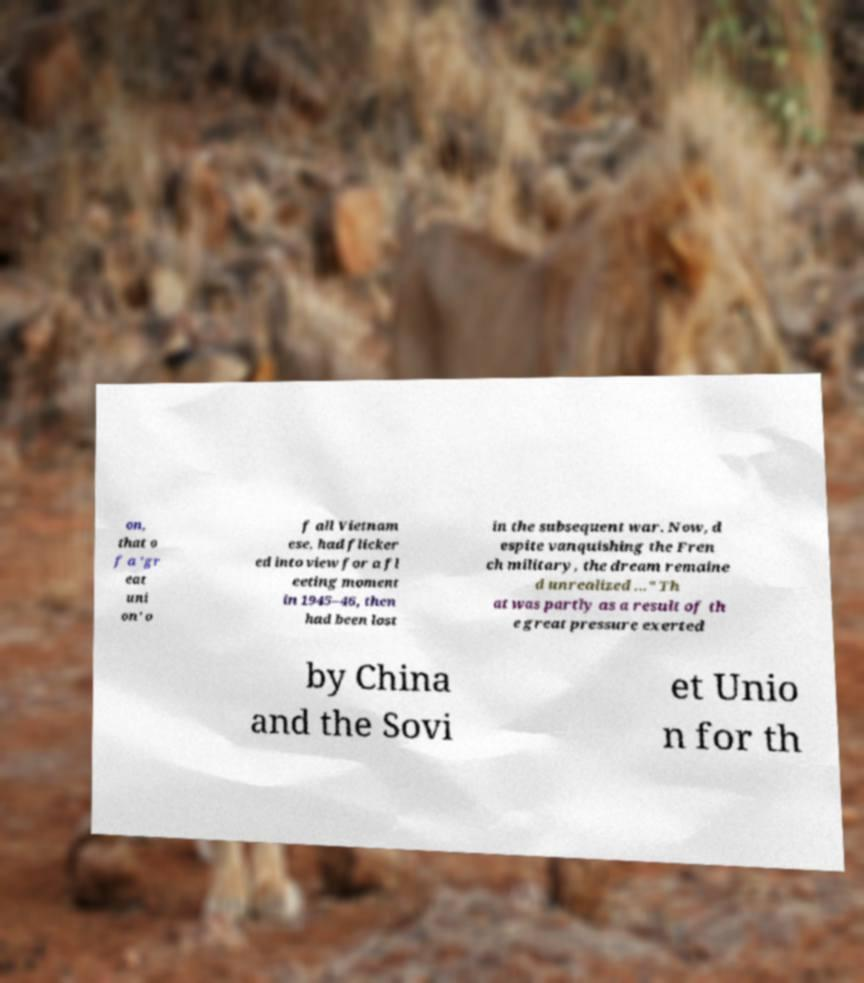Please identify and transcribe the text found in this image. on, that o f a 'gr eat uni on' o f all Vietnam ese, had flicker ed into view for a fl eeting moment in 1945–46, then had been lost in the subsequent war. Now, d espite vanquishing the Fren ch military, the dream remaine d unrealized ..." Th at was partly as a result of th e great pressure exerted by China and the Sovi et Unio n for th 